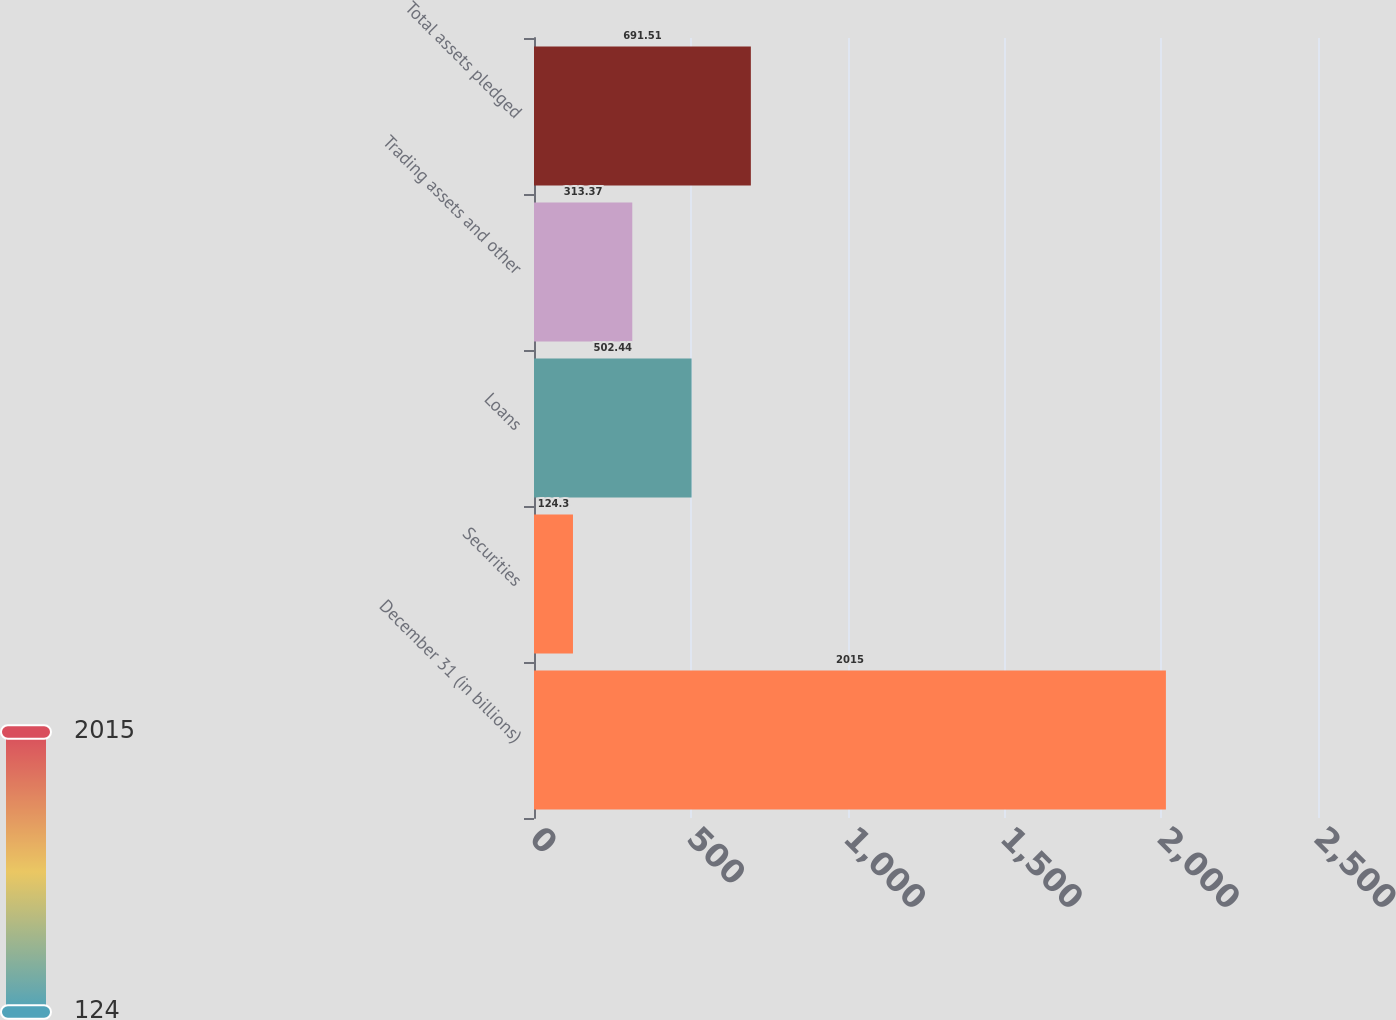Convert chart to OTSL. <chart><loc_0><loc_0><loc_500><loc_500><bar_chart><fcel>December 31 (in billions)<fcel>Securities<fcel>Loans<fcel>Trading assets and other<fcel>Total assets pledged<nl><fcel>2015<fcel>124.3<fcel>502.44<fcel>313.37<fcel>691.51<nl></chart> 